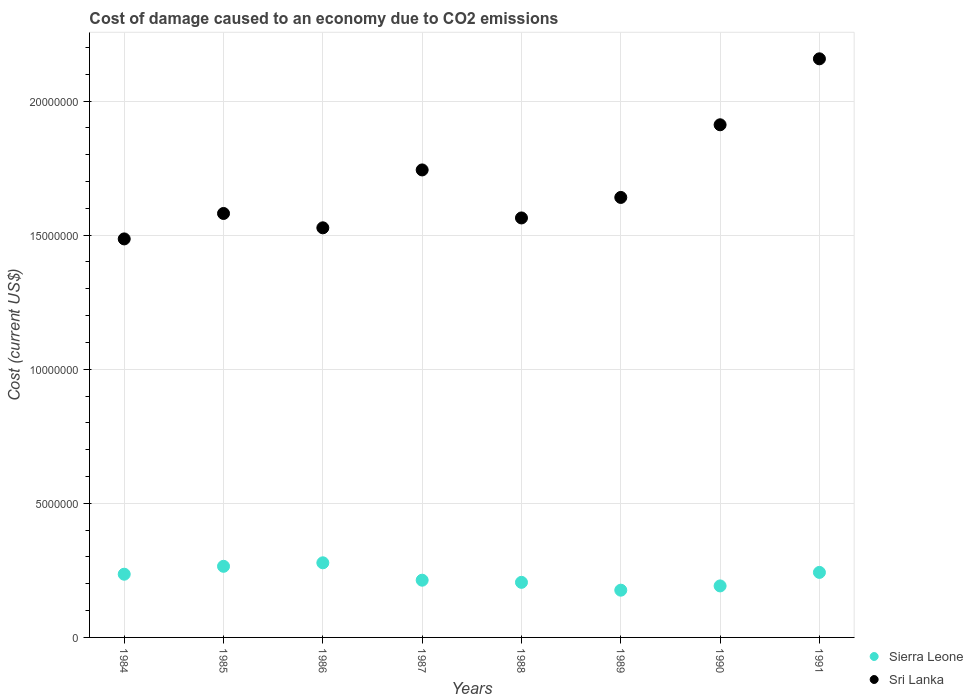Is the number of dotlines equal to the number of legend labels?
Offer a very short reply. Yes. What is the cost of damage caused due to CO2 emissisons in Sri Lanka in 1989?
Your response must be concise. 1.64e+07. Across all years, what is the maximum cost of damage caused due to CO2 emissisons in Sri Lanka?
Your response must be concise. 2.16e+07. Across all years, what is the minimum cost of damage caused due to CO2 emissisons in Sierra Leone?
Your answer should be very brief. 1.76e+06. In which year was the cost of damage caused due to CO2 emissisons in Sri Lanka minimum?
Offer a very short reply. 1984. What is the total cost of damage caused due to CO2 emissisons in Sierra Leone in the graph?
Give a very brief answer. 1.81e+07. What is the difference between the cost of damage caused due to CO2 emissisons in Sierra Leone in 1986 and that in 1989?
Give a very brief answer. 1.02e+06. What is the difference between the cost of damage caused due to CO2 emissisons in Sierra Leone in 1991 and the cost of damage caused due to CO2 emissisons in Sri Lanka in 1990?
Keep it short and to the point. -1.67e+07. What is the average cost of damage caused due to CO2 emissisons in Sri Lanka per year?
Make the answer very short. 1.70e+07. In the year 1990, what is the difference between the cost of damage caused due to CO2 emissisons in Sri Lanka and cost of damage caused due to CO2 emissisons in Sierra Leone?
Provide a succinct answer. 1.72e+07. What is the ratio of the cost of damage caused due to CO2 emissisons in Sri Lanka in 1990 to that in 1991?
Keep it short and to the point. 0.89. Is the cost of damage caused due to CO2 emissisons in Sierra Leone in 1987 less than that in 1990?
Provide a short and direct response. No. Is the difference between the cost of damage caused due to CO2 emissisons in Sri Lanka in 1985 and 1991 greater than the difference between the cost of damage caused due to CO2 emissisons in Sierra Leone in 1985 and 1991?
Your answer should be compact. No. What is the difference between the highest and the second highest cost of damage caused due to CO2 emissisons in Sri Lanka?
Your answer should be compact. 2.46e+06. What is the difference between the highest and the lowest cost of damage caused due to CO2 emissisons in Sri Lanka?
Keep it short and to the point. 6.72e+06. Does the cost of damage caused due to CO2 emissisons in Sierra Leone monotonically increase over the years?
Your answer should be very brief. No. Is the cost of damage caused due to CO2 emissisons in Sri Lanka strictly greater than the cost of damage caused due to CO2 emissisons in Sierra Leone over the years?
Give a very brief answer. Yes. How many dotlines are there?
Your response must be concise. 2. What is the difference between two consecutive major ticks on the Y-axis?
Give a very brief answer. 5.00e+06. Does the graph contain any zero values?
Offer a terse response. No. Does the graph contain grids?
Provide a short and direct response. Yes. Where does the legend appear in the graph?
Ensure brevity in your answer.  Bottom right. How many legend labels are there?
Your answer should be very brief. 2. What is the title of the graph?
Ensure brevity in your answer.  Cost of damage caused to an economy due to CO2 emissions. What is the label or title of the Y-axis?
Your answer should be very brief. Cost (current US$). What is the Cost (current US$) of Sierra Leone in 1984?
Ensure brevity in your answer.  2.36e+06. What is the Cost (current US$) in Sri Lanka in 1984?
Offer a very short reply. 1.49e+07. What is the Cost (current US$) in Sierra Leone in 1985?
Make the answer very short. 2.65e+06. What is the Cost (current US$) of Sri Lanka in 1985?
Provide a succinct answer. 1.58e+07. What is the Cost (current US$) of Sierra Leone in 1986?
Make the answer very short. 2.78e+06. What is the Cost (current US$) in Sri Lanka in 1986?
Your answer should be very brief. 1.53e+07. What is the Cost (current US$) of Sierra Leone in 1987?
Ensure brevity in your answer.  2.13e+06. What is the Cost (current US$) of Sri Lanka in 1987?
Give a very brief answer. 1.74e+07. What is the Cost (current US$) in Sierra Leone in 1988?
Give a very brief answer. 2.05e+06. What is the Cost (current US$) of Sri Lanka in 1988?
Your response must be concise. 1.56e+07. What is the Cost (current US$) of Sierra Leone in 1989?
Give a very brief answer. 1.76e+06. What is the Cost (current US$) of Sri Lanka in 1989?
Your answer should be compact. 1.64e+07. What is the Cost (current US$) of Sierra Leone in 1990?
Provide a short and direct response. 1.92e+06. What is the Cost (current US$) in Sri Lanka in 1990?
Your answer should be very brief. 1.91e+07. What is the Cost (current US$) in Sierra Leone in 1991?
Ensure brevity in your answer.  2.42e+06. What is the Cost (current US$) in Sri Lanka in 1991?
Offer a very short reply. 2.16e+07. Across all years, what is the maximum Cost (current US$) of Sierra Leone?
Your response must be concise. 2.78e+06. Across all years, what is the maximum Cost (current US$) in Sri Lanka?
Make the answer very short. 2.16e+07. Across all years, what is the minimum Cost (current US$) of Sierra Leone?
Ensure brevity in your answer.  1.76e+06. Across all years, what is the minimum Cost (current US$) of Sri Lanka?
Your answer should be very brief. 1.49e+07. What is the total Cost (current US$) in Sierra Leone in the graph?
Your response must be concise. 1.81e+07. What is the total Cost (current US$) of Sri Lanka in the graph?
Provide a short and direct response. 1.36e+08. What is the difference between the Cost (current US$) of Sierra Leone in 1984 and that in 1985?
Provide a short and direct response. -2.94e+05. What is the difference between the Cost (current US$) in Sri Lanka in 1984 and that in 1985?
Offer a terse response. -9.49e+05. What is the difference between the Cost (current US$) in Sierra Leone in 1984 and that in 1986?
Ensure brevity in your answer.  -4.25e+05. What is the difference between the Cost (current US$) of Sri Lanka in 1984 and that in 1986?
Keep it short and to the point. -4.14e+05. What is the difference between the Cost (current US$) of Sierra Leone in 1984 and that in 1987?
Offer a very short reply. 2.23e+05. What is the difference between the Cost (current US$) in Sri Lanka in 1984 and that in 1987?
Your answer should be compact. -2.57e+06. What is the difference between the Cost (current US$) in Sierra Leone in 1984 and that in 1988?
Give a very brief answer. 3.04e+05. What is the difference between the Cost (current US$) in Sri Lanka in 1984 and that in 1988?
Give a very brief answer. -7.82e+05. What is the difference between the Cost (current US$) of Sierra Leone in 1984 and that in 1989?
Keep it short and to the point. 5.96e+05. What is the difference between the Cost (current US$) of Sri Lanka in 1984 and that in 1989?
Provide a short and direct response. -1.55e+06. What is the difference between the Cost (current US$) in Sierra Leone in 1984 and that in 1990?
Provide a short and direct response. 4.37e+05. What is the difference between the Cost (current US$) of Sri Lanka in 1984 and that in 1990?
Your answer should be compact. -4.26e+06. What is the difference between the Cost (current US$) in Sierra Leone in 1984 and that in 1991?
Your response must be concise. -6.72e+04. What is the difference between the Cost (current US$) in Sri Lanka in 1984 and that in 1991?
Ensure brevity in your answer.  -6.72e+06. What is the difference between the Cost (current US$) in Sierra Leone in 1985 and that in 1986?
Ensure brevity in your answer.  -1.31e+05. What is the difference between the Cost (current US$) in Sri Lanka in 1985 and that in 1986?
Make the answer very short. 5.35e+05. What is the difference between the Cost (current US$) in Sierra Leone in 1985 and that in 1987?
Offer a terse response. 5.18e+05. What is the difference between the Cost (current US$) of Sri Lanka in 1985 and that in 1987?
Offer a very short reply. -1.62e+06. What is the difference between the Cost (current US$) of Sierra Leone in 1985 and that in 1988?
Give a very brief answer. 5.98e+05. What is the difference between the Cost (current US$) of Sri Lanka in 1985 and that in 1988?
Make the answer very short. 1.67e+05. What is the difference between the Cost (current US$) in Sierra Leone in 1985 and that in 1989?
Provide a succinct answer. 8.90e+05. What is the difference between the Cost (current US$) of Sri Lanka in 1985 and that in 1989?
Provide a short and direct response. -5.98e+05. What is the difference between the Cost (current US$) of Sierra Leone in 1985 and that in 1990?
Keep it short and to the point. 7.31e+05. What is the difference between the Cost (current US$) of Sri Lanka in 1985 and that in 1990?
Keep it short and to the point. -3.31e+06. What is the difference between the Cost (current US$) of Sierra Leone in 1985 and that in 1991?
Give a very brief answer. 2.27e+05. What is the difference between the Cost (current US$) of Sri Lanka in 1985 and that in 1991?
Make the answer very short. -5.77e+06. What is the difference between the Cost (current US$) of Sierra Leone in 1986 and that in 1987?
Offer a terse response. 6.49e+05. What is the difference between the Cost (current US$) of Sri Lanka in 1986 and that in 1987?
Your answer should be very brief. -2.16e+06. What is the difference between the Cost (current US$) of Sierra Leone in 1986 and that in 1988?
Provide a short and direct response. 7.29e+05. What is the difference between the Cost (current US$) in Sri Lanka in 1986 and that in 1988?
Your response must be concise. -3.68e+05. What is the difference between the Cost (current US$) in Sierra Leone in 1986 and that in 1989?
Give a very brief answer. 1.02e+06. What is the difference between the Cost (current US$) of Sri Lanka in 1986 and that in 1989?
Provide a succinct answer. -1.13e+06. What is the difference between the Cost (current US$) of Sierra Leone in 1986 and that in 1990?
Give a very brief answer. 8.62e+05. What is the difference between the Cost (current US$) in Sri Lanka in 1986 and that in 1990?
Provide a succinct answer. -3.84e+06. What is the difference between the Cost (current US$) of Sierra Leone in 1986 and that in 1991?
Ensure brevity in your answer.  3.58e+05. What is the difference between the Cost (current US$) in Sri Lanka in 1986 and that in 1991?
Your response must be concise. -6.30e+06. What is the difference between the Cost (current US$) of Sierra Leone in 1987 and that in 1988?
Provide a succinct answer. 8.01e+04. What is the difference between the Cost (current US$) of Sri Lanka in 1987 and that in 1988?
Your answer should be compact. 1.79e+06. What is the difference between the Cost (current US$) in Sierra Leone in 1987 and that in 1989?
Give a very brief answer. 3.72e+05. What is the difference between the Cost (current US$) of Sri Lanka in 1987 and that in 1989?
Your answer should be compact. 1.03e+06. What is the difference between the Cost (current US$) in Sierra Leone in 1987 and that in 1990?
Make the answer very short. 2.13e+05. What is the difference between the Cost (current US$) of Sri Lanka in 1987 and that in 1990?
Ensure brevity in your answer.  -1.68e+06. What is the difference between the Cost (current US$) in Sierra Leone in 1987 and that in 1991?
Your answer should be compact. -2.91e+05. What is the difference between the Cost (current US$) in Sri Lanka in 1987 and that in 1991?
Provide a succinct answer. -4.14e+06. What is the difference between the Cost (current US$) of Sierra Leone in 1988 and that in 1989?
Your answer should be very brief. 2.92e+05. What is the difference between the Cost (current US$) in Sri Lanka in 1988 and that in 1989?
Provide a succinct answer. -7.65e+05. What is the difference between the Cost (current US$) in Sierra Leone in 1988 and that in 1990?
Your answer should be compact. 1.33e+05. What is the difference between the Cost (current US$) of Sri Lanka in 1988 and that in 1990?
Your answer should be very brief. -3.47e+06. What is the difference between the Cost (current US$) of Sierra Leone in 1988 and that in 1991?
Ensure brevity in your answer.  -3.71e+05. What is the difference between the Cost (current US$) of Sri Lanka in 1988 and that in 1991?
Your response must be concise. -5.93e+06. What is the difference between the Cost (current US$) of Sierra Leone in 1989 and that in 1990?
Offer a terse response. -1.59e+05. What is the difference between the Cost (current US$) in Sri Lanka in 1989 and that in 1990?
Offer a very short reply. -2.71e+06. What is the difference between the Cost (current US$) in Sierra Leone in 1989 and that in 1991?
Provide a short and direct response. -6.63e+05. What is the difference between the Cost (current US$) in Sri Lanka in 1989 and that in 1991?
Offer a terse response. -5.17e+06. What is the difference between the Cost (current US$) of Sierra Leone in 1990 and that in 1991?
Offer a very short reply. -5.04e+05. What is the difference between the Cost (current US$) of Sri Lanka in 1990 and that in 1991?
Your answer should be compact. -2.46e+06. What is the difference between the Cost (current US$) in Sierra Leone in 1984 and the Cost (current US$) in Sri Lanka in 1985?
Provide a short and direct response. -1.35e+07. What is the difference between the Cost (current US$) in Sierra Leone in 1984 and the Cost (current US$) in Sri Lanka in 1986?
Offer a very short reply. -1.29e+07. What is the difference between the Cost (current US$) of Sierra Leone in 1984 and the Cost (current US$) of Sri Lanka in 1987?
Give a very brief answer. -1.51e+07. What is the difference between the Cost (current US$) of Sierra Leone in 1984 and the Cost (current US$) of Sri Lanka in 1988?
Keep it short and to the point. -1.33e+07. What is the difference between the Cost (current US$) of Sierra Leone in 1984 and the Cost (current US$) of Sri Lanka in 1989?
Offer a terse response. -1.40e+07. What is the difference between the Cost (current US$) of Sierra Leone in 1984 and the Cost (current US$) of Sri Lanka in 1990?
Give a very brief answer. -1.68e+07. What is the difference between the Cost (current US$) of Sierra Leone in 1984 and the Cost (current US$) of Sri Lanka in 1991?
Keep it short and to the point. -1.92e+07. What is the difference between the Cost (current US$) in Sierra Leone in 1985 and the Cost (current US$) in Sri Lanka in 1986?
Offer a very short reply. -1.26e+07. What is the difference between the Cost (current US$) in Sierra Leone in 1985 and the Cost (current US$) in Sri Lanka in 1987?
Your response must be concise. -1.48e+07. What is the difference between the Cost (current US$) of Sierra Leone in 1985 and the Cost (current US$) of Sri Lanka in 1988?
Make the answer very short. -1.30e+07. What is the difference between the Cost (current US$) in Sierra Leone in 1985 and the Cost (current US$) in Sri Lanka in 1989?
Give a very brief answer. -1.38e+07. What is the difference between the Cost (current US$) in Sierra Leone in 1985 and the Cost (current US$) in Sri Lanka in 1990?
Provide a succinct answer. -1.65e+07. What is the difference between the Cost (current US$) of Sierra Leone in 1985 and the Cost (current US$) of Sri Lanka in 1991?
Keep it short and to the point. -1.89e+07. What is the difference between the Cost (current US$) of Sierra Leone in 1986 and the Cost (current US$) of Sri Lanka in 1987?
Provide a short and direct response. -1.47e+07. What is the difference between the Cost (current US$) in Sierra Leone in 1986 and the Cost (current US$) in Sri Lanka in 1988?
Give a very brief answer. -1.29e+07. What is the difference between the Cost (current US$) in Sierra Leone in 1986 and the Cost (current US$) in Sri Lanka in 1989?
Provide a short and direct response. -1.36e+07. What is the difference between the Cost (current US$) in Sierra Leone in 1986 and the Cost (current US$) in Sri Lanka in 1990?
Provide a short and direct response. -1.63e+07. What is the difference between the Cost (current US$) of Sierra Leone in 1986 and the Cost (current US$) of Sri Lanka in 1991?
Offer a terse response. -1.88e+07. What is the difference between the Cost (current US$) in Sierra Leone in 1987 and the Cost (current US$) in Sri Lanka in 1988?
Your response must be concise. -1.35e+07. What is the difference between the Cost (current US$) of Sierra Leone in 1987 and the Cost (current US$) of Sri Lanka in 1989?
Ensure brevity in your answer.  -1.43e+07. What is the difference between the Cost (current US$) in Sierra Leone in 1987 and the Cost (current US$) in Sri Lanka in 1990?
Give a very brief answer. -1.70e+07. What is the difference between the Cost (current US$) of Sierra Leone in 1987 and the Cost (current US$) of Sri Lanka in 1991?
Give a very brief answer. -1.94e+07. What is the difference between the Cost (current US$) of Sierra Leone in 1988 and the Cost (current US$) of Sri Lanka in 1989?
Offer a terse response. -1.44e+07. What is the difference between the Cost (current US$) in Sierra Leone in 1988 and the Cost (current US$) in Sri Lanka in 1990?
Your answer should be compact. -1.71e+07. What is the difference between the Cost (current US$) in Sierra Leone in 1988 and the Cost (current US$) in Sri Lanka in 1991?
Provide a succinct answer. -1.95e+07. What is the difference between the Cost (current US$) of Sierra Leone in 1989 and the Cost (current US$) of Sri Lanka in 1990?
Make the answer very short. -1.74e+07. What is the difference between the Cost (current US$) of Sierra Leone in 1989 and the Cost (current US$) of Sri Lanka in 1991?
Ensure brevity in your answer.  -1.98e+07. What is the difference between the Cost (current US$) in Sierra Leone in 1990 and the Cost (current US$) in Sri Lanka in 1991?
Give a very brief answer. -1.97e+07. What is the average Cost (current US$) in Sierra Leone per year?
Provide a short and direct response. 2.26e+06. What is the average Cost (current US$) of Sri Lanka per year?
Ensure brevity in your answer.  1.70e+07. In the year 1984, what is the difference between the Cost (current US$) of Sierra Leone and Cost (current US$) of Sri Lanka?
Ensure brevity in your answer.  -1.25e+07. In the year 1985, what is the difference between the Cost (current US$) in Sierra Leone and Cost (current US$) in Sri Lanka?
Ensure brevity in your answer.  -1.32e+07. In the year 1986, what is the difference between the Cost (current US$) in Sierra Leone and Cost (current US$) in Sri Lanka?
Give a very brief answer. -1.25e+07. In the year 1987, what is the difference between the Cost (current US$) of Sierra Leone and Cost (current US$) of Sri Lanka?
Provide a succinct answer. -1.53e+07. In the year 1988, what is the difference between the Cost (current US$) of Sierra Leone and Cost (current US$) of Sri Lanka?
Keep it short and to the point. -1.36e+07. In the year 1989, what is the difference between the Cost (current US$) in Sierra Leone and Cost (current US$) in Sri Lanka?
Provide a succinct answer. -1.46e+07. In the year 1990, what is the difference between the Cost (current US$) in Sierra Leone and Cost (current US$) in Sri Lanka?
Provide a short and direct response. -1.72e+07. In the year 1991, what is the difference between the Cost (current US$) in Sierra Leone and Cost (current US$) in Sri Lanka?
Ensure brevity in your answer.  -1.92e+07. What is the ratio of the Cost (current US$) in Sierra Leone in 1984 to that in 1985?
Your answer should be very brief. 0.89. What is the ratio of the Cost (current US$) in Sierra Leone in 1984 to that in 1986?
Provide a succinct answer. 0.85. What is the ratio of the Cost (current US$) of Sri Lanka in 1984 to that in 1986?
Offer a terse response. 0.97. What is the ratio of the Cost (current US$) of Sierra Leone in 1984 to that in 1987?
Ensure brevity in your answer.  1.1. What is the ratio of the Cost (current US$) of Sri Lanka in 1984 to that in 1987?
Your response must be concise. 0.85. What is the ratio of the Cost (current US$) of Sierra Leone in 1984 to that in 1988?
Your answer should be compact. 1.15. What is the ratio of the Cost (current US$) in Sri Lanka in 1984 to that in 1988?
Your answer should be very brief. 0.95. What is the ratio of the Cost (current US$) of Sierra Leone in 1984 to that in 1989?
Provide a short and direct response. 1.34. What is the ratio of the Cost (current US$) of Sri Lanka in 1984 to that in 1989?
Give a very brief answer. 0.91. What is the ratio of the Cost (current US$) of Sierra Leone in 1984 to that in 1990?
Your answer should be very brief. 1.23. What is the ratio of the Cost (current US$) of Sri Lanka in 1984 to that in 1990?
Keep it short and to the point. 0.78. What is the ratio of the Cost (current US$) in Sierra Leone in 1984 to that in 1991?
Provide a short and direct response. 0.97. What is the ratio of the Cost (current US$) in Sri Lanka in 1984 to that in 1991?
Ensure brevity in your answer.  0.69. What is the ratio of the Cost (current US$) in Sierra Leone in 1985 to that in 1986?
Provide a succinct answer. 0.95. What is the ratio of the Cost (current US$) in Sri Lanka in 1985 to that in 1986?
Offer a very short reply. 1.03. What is the ratio of the Cost (current US$) in Sierra Leone in 1985 to that in 1987?
Your answer should be compact. 1.24. What is the ratio of the Cost (current US$) of Sri Lanka in 1985 to that in 1987?
Make the answer very short. 0.91. What is the ratio of the Cost (current US$) of Sierra Leone in 1985 to that in 1988?
Offer a terse response. 1.29. What is the ratio of the Cost (current US$) in Sri Lanka in 1985 to that in 1988?
Your answer should be compact. 1.01. What is the ratio of the Cost (current US$) in Sierra Leone in 1985 to that in 1989?
Your answer should be very brief. 1.51. What is the ratio of the Cost (current US$) in Sri Lanka in 1985 to that in 1989?
Make the answer very short. 0.96. What is the ratio of the Cost (current US$) of Sierra Leone in 1985 to that in 1990?
Your answer should be very brief. 1.38. What is the ratio of the Cost (current US$) of Sri Lanka in 1985 to that in 1990?
Provide a short and direct response. 0.83. What is the ratio of the Cost (current US$) of Sierra Leone in 1985 to that in 1991?
Provide a succinct answer. 1.09. What is the ratio of the Cost (current US$) of Sri Lanka in 1985 to that in 1991?
Give a very brief answer. 0.73. What is the ratio of the Cost (current US$) of Sierra Leone in 1986 to that in 1987?
Give a very brief answer. 1.3. What is the ratio of the Cost (current US$) in Sri Lanka in 1986 to that in 1987?
Make the answer very short. 0.88. What is the ratio of the Cost (current US$) in Sierra Leone in 1986 to that in 1988?
Keep it short and to the point. 1.35. What is the ratio of the Cost (current US$) in Sri Lanka in 1986 to that in 1988?
Keep it short and to the point. 0.98. What is the ratio of the Cost (current US$) in Sierra Leone in 1986 to that in 1989?
Provide a short and direct response. 1.58. What is the ratio of the Cost (current US$) in Sri Lanka in 1986 to that in 1989?
Keep it short and to the point. 0.93. What is the ratio of the Cost (current US$) of Sierra Leone in 1986 to that in 1990?
Provide a short and direct response. 1.45. What is the ratio of the Cost (current US$) in Sri Lanka in 1986 to that in 1990?
Your answer should be very brief. 0.8. What is the ratio of the Cost (current US$) in Sierra Leone in 1986 to that in 1991?
Your answer should be very brief. 1.15. What is the ratio of the Cost (current US$) in Sri Lanka in 1986 to that in 1991?
Your answer should be very brief. 0.71. What is the ratio of the Cost (current US$) in Sierra Leone in 1987 to that in 1988?
Offer a terse response. 1.04. What is the ratio of the Cost (current US$) of Sri Lanka in 1987 to that in 1988?
Offer a very short reply. 1.11. What is the ratio of the Cost (current US$) in Sierra Leone in 1987 to that in 1989?
Keep it short and to the point. 1.21. What is the ratio of the Cost (current US$) of Sri Lanka in 1987 to that in 1989?
Make the answer very short. 1.06. What is the ratio of the Cost (current US$) in Sierra Leone in 1987 to that in 1990?
Offer a very short reply. 1.11. What is the ratio of the Cost (current US$) of Sri Lanka in 1987 to that in 1990?
Give a very brief answer. 0.91. What is the ratio of the Cost (current US$) in Sierra Leone in 1987 to that in 1991?
Ensure brevity in your answer.  0.88. What is the ratio of the Cost (current US$) in Sri Lanka in 1987 to that in 1991?
Your answer should be compact. 0.81. What is the ratio of the Cost (current US$) in Sierra Leone in 1988 to that in 1989?
Provide a succinct answer. 1.17. What is the ratio of the Cost (current US$) in Sri Lanka in 1988 to that in 1989?
Provide a succinct answer. 0.95. What is the ratio of the Cost (current US$) of Sierra Leone in 1988 to that in 1990?
Your response must be concise. 1.07. What is the ratio of the Cost (current US$) of Sri Lanka in 1988 to that in 1990?
Offer a terse response. 0.82. What is the ratio of the Cost (current US$) of Sierra Leone in 1988 to that in 1991?
Ensure brevity in your answer.  0.85. What is the ratio of the Cost (current US$) of Sri Lanka in 1988 to that in 1991?
Offer a very short reply. 0.72. What is the ratio of the Cost (current US$) in Sierra Leone in 1989 to that in 1990?
Your answer should be very brief. 0.92. What is the ratio of the Cost (current US$) in Sri Lanka in 1989 to that in 1990?
Your response must be concise. 0.86. What is the ratio of the Cost (current US$) of Sierra Leone in 1989 to that in 1991?
Keep it short and to the point. 0.73. What is the ratio of the Cost (current US$) of Sri Lanka in 1989 to that in 1991?
Your response must be concise. 0.76. What is the ratio of the Cost (current US$) of Sierra Leone in 1990 to that in 1991?
Keep it short and to the point. 0.79. What is the ratio of the Cost (current US$) of Sri Lanka in 1990 to that in 1991?
Keep it short and to the point. 0.89. What is the difference between the highest and the second highest Cost (current US$) in Sierra Leone?
Provide a succinct answer. 1.31e+05. What is the difference between the highest and the second highest Cost (current US$) of Sri Lanka?
Give a very brief answer. 2.46e+06. What is the difference between the highest and the lowest Cost (current US$) in Sierra Leone?
Ensure brevity in your answer.  1.02e+06. What is the difference between the highest and the lowest Cost (current US$) in Sri Lanka?
Provide a succinct answer. 6.72e+06. 